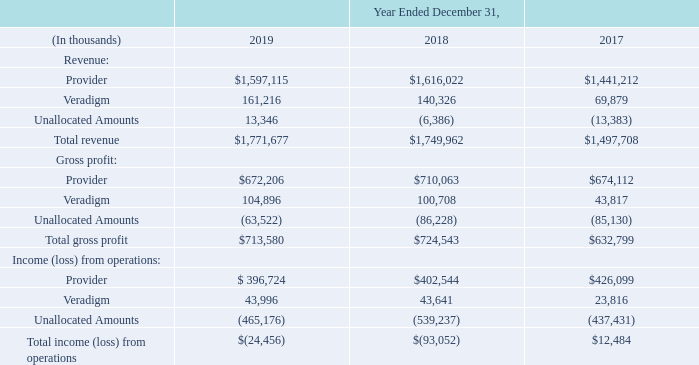18. Business Segments
We primarily derive our revenues from sales of our proprietary software (either as a direct license sale or under a subscription delivery model), which also serves as the basis for our recurring service contracts for software support and maintenance and certain transaction-related services. In addition, we provide various other client services, including installation, and managed services such as outsourcing, private cloud hosting and revenue cycle management.
During the first quarter of 2019, we realigned our reporting structure as a result of the divestiture of our investment in Netsmart on December 31, 2018, the evolution of the healthcare IT industry and our increased focus on the payer and life sciences market. As a result, we changed the presentation of our reportable segments to Provider and Veradigm. The new Provider segment is comprised of our core integrated clinical software applications, financial management and patient engagement solutions targeted at clients across the entire continuum of care. The new Veradigm segment primarily focuses on the payer and life sciences market. These changes to our reportable segments had no impact on operating segments. The segment disclosures below for the years ended December 31, 2018 and 2017 have been revised to our current presentation.
We sold all of our investment in Netsmart on December 31, 2018. Prior to the sale, Netsmart comprised a separate reportable segment, which due to its significance to our historical consolidated financial statements and results of operations, is reported as a discontinued operation as a result of the sale. In addition, the results of operations related to two of the product offerings acquired with the EIS Business (Horizon Clinicals and Series2000) are also presented throughout these financial statements as discontinued operations and are included within the Provider reportable segment, except for acquisition-related deferred revenue adjustments, which are included in “Unallocated Amounts”. Refer to Note 17, “Discontinued Operations.”
As a result of the above changes, as of December 31, 2019, we had eight operating segments, which are aggregated into two reportable segments. The Provider reportable segment includes the Hospitals and Health Systems, Ambulatory, CarePort, FollowMyHealth®, EPSiTM, EIS-Classics and 2bPrecise strategic business units, each of which represents a separate operating segment. This reportable segment derives its revenue from the sale of integrated clinical software applications, financial management and patient engagement solutions, which primarily include EHR-related software, connectivity and coordinated care solutions, financial and practice management software, related installation, support and maintenance, outsourcing, private cloud hosting, revenue cycle management, training and electronic claims administration services. The Veradigm reportable segment is comprised of the Veradigm business unit, which represents a separate operating segment. This reportable segment provides data-driven clinical insights with actionable tools for clinical workflow, research, analytics and media. Its solutions, targeted at key healthcare stakeholders, help improve the quality, efficiency and value of healthcare delivery.
Our Chief Operating Decision Maker (“CODM”) uses segment revenues, gross profit and income from operations as measures of performance and to make decisions about the allocation of resources. In determining these performance measures, we do not include in revenue the amortization of acquisition- related deferred revenue adjustments, which reflect the fair value adjustments to deferred revenue acquired in a business combination. We also exclude the amortization of intangible assets, stock-based compensation expense, non-recurring expenses and transaction-related costs, and non-cash asset impairment charges from the operating segment data provided to our CODM. Non-recurring expenses relate to certain severance, product consolidation, legal, consulting and other charges incurred in connection with activities that are considered one-time. Accordingly, these amounts are not included in our reportable segment results and are included in an “Unallocated Amounts” category within our segment disclosure. The “Unallocated Amounts” category also includes (i) corporate general and administrative expenses (including marketing expenses) and certain research and development expenses related to common solutions and resources that benefit all of our business units (refer to discussion above), all of which are centrally managed and (ii) revenue and the associated cost from the resale of certain ancillary products, primarily hardware. We do not track our assets by segment.
What is the total revenue in 2019?
Answer scale should be: thousand. $1,771,677. What is the total revenue in 2018?
Answer scale should be: thousand. $1,749,962. What is the total revenue in 2017?
Answer scale should be: thousand. $1,497,708. What is the change in Revenue from Provider between 2018 and 2017?
Answer scale should be: thousand. 1,616,022-1,441,212
Answer: 174810. What is the change in Revenue from Veradigm between 2018 and 2017?
Answer scale should be: thousand. 140,326-69,879
Answer: 70447. Which year has the highest total revenue? $1,771,677>$1,749,962>$1,497,708
Answer: 2019. 